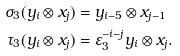<formula> <loc_0><loc_0><loc_500><loc_500>\sigma _ { 3 } ( y _ { i } \otimes x _ { j } ) & = y _ { i - 5 } \otimes x _ { j - 1 } \\ \tau _ { 3 } ( y _ { i } \otimes x _ { j } ) & = \varepsilon _ { 3 } ^ { - i - j } y _ { i } \otimes x _ { j } .</formula> 